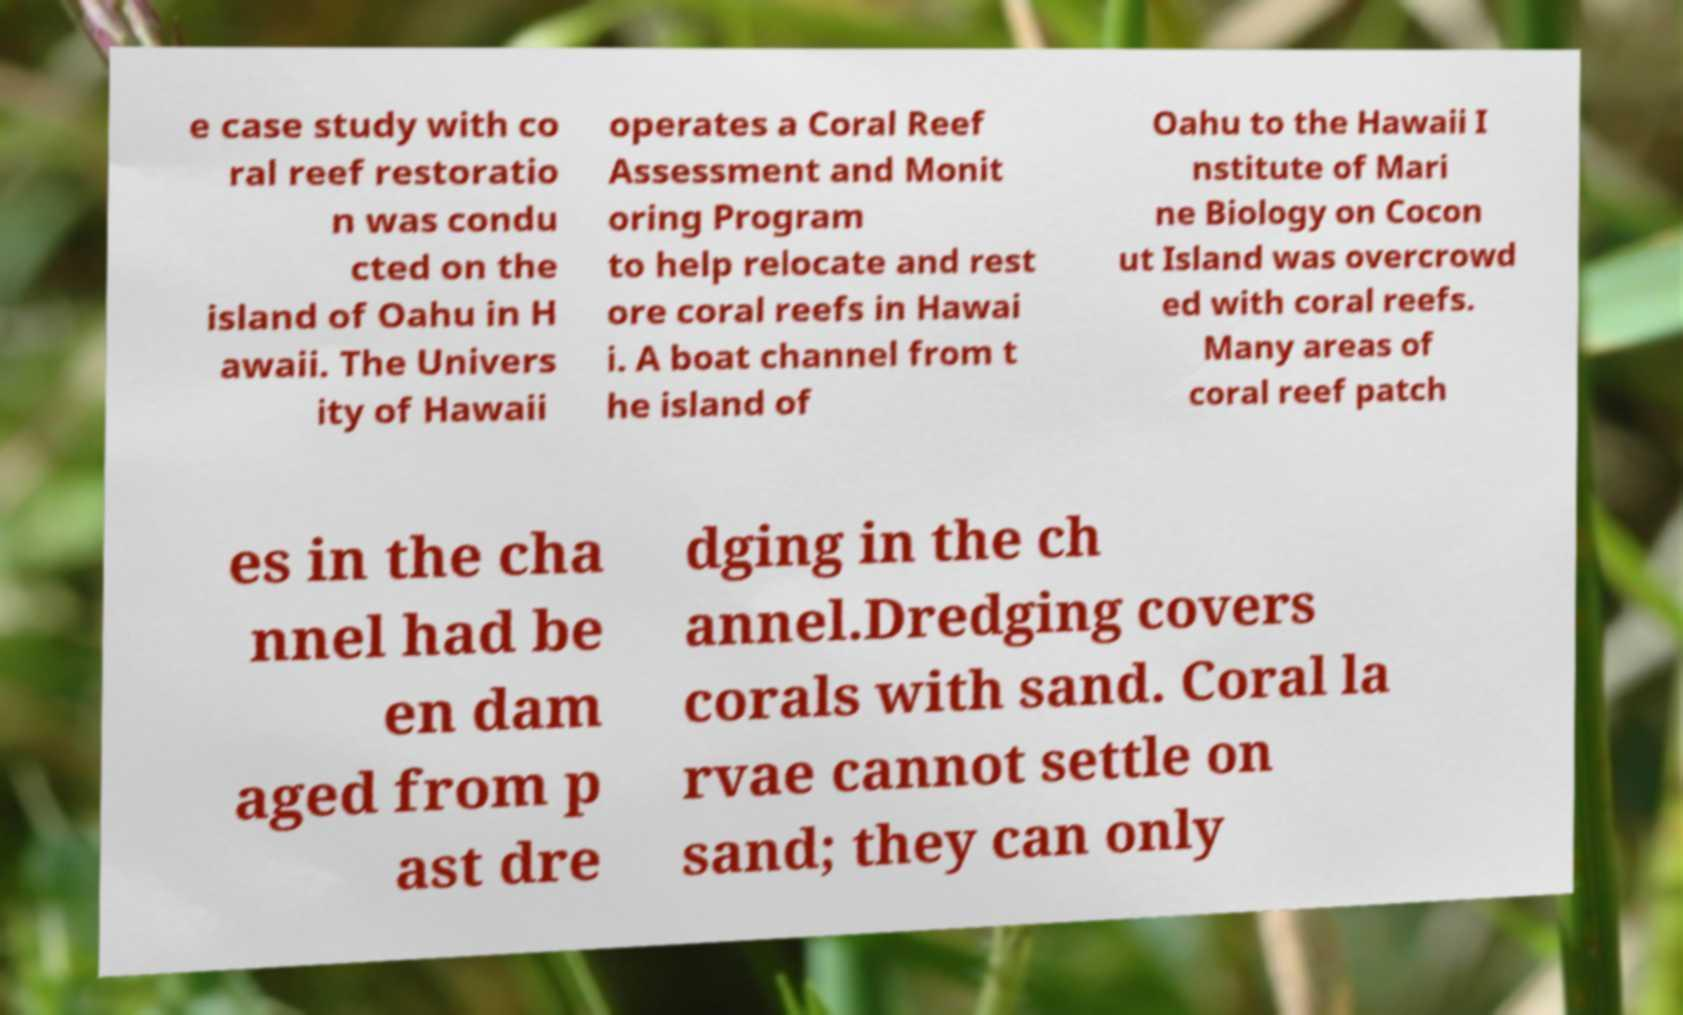Can you read and provide the text displayed in the image?This photo seems to have some interesting text. Can you extract and type it out for me? e case study with co ral reef restoratio n was condu cted on the island of Oahu in H awaii. The Univers ity of Hawaii operates a Coral Reef Assessment and Monit oring Program to help relocate and rest ore coral reefs in Hawai i. A boat channel from t he island of Oahu to the Hawaii I nstitute of Mari ne Biology on Cocon ut Island was overcrowd ed with coral reefs. Many areas of coral reef patch es in the cha nnel had be en dam aged from p ast dre dging in the ch annel.Dredging covers corals with sand. Coral la rvae cannot settle on sand; they can only 